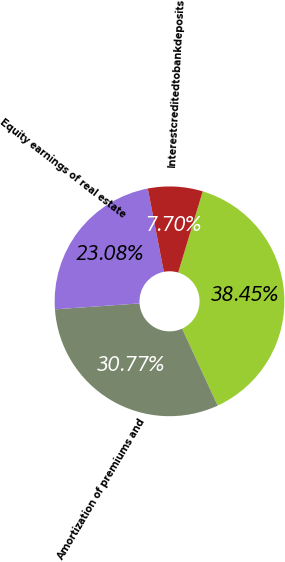Convert chart to OTSL. <chart><loc_0><loc_0><loc_500><loc_500><pie_chart><ecel><fcel>Amortization of premiums and<fcel>Equity earnings of real estate<fcel>Interestcreditedtobankdeposits<nl><fcel>38.45%<fcel>30.77%<fcel>23.08%<fcel>7.7%<nl></chart> 